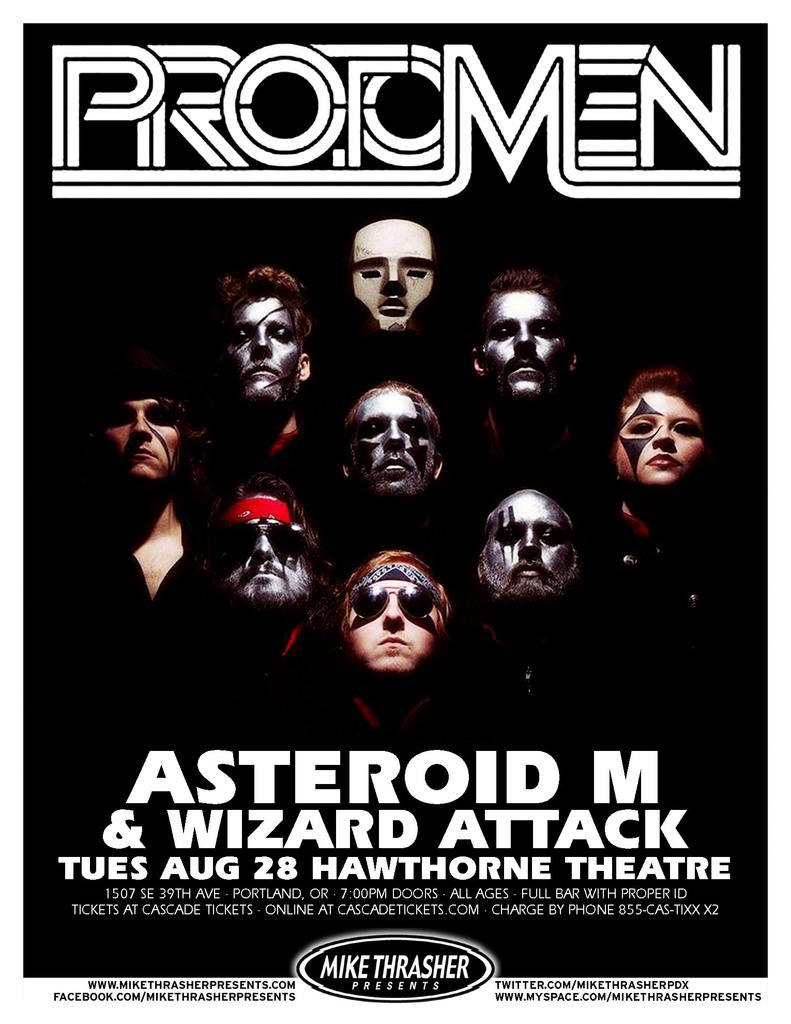<image>
Offer a succinct explanation of the picture presented. An event at Hawthorne Theatre is scheduled for Tues, Aug 28. 